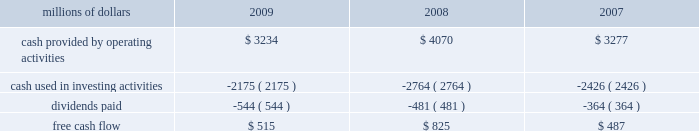2022 asset utilization 2013 in response to economic conditions and lower revenue in 2009 , we implemented productivity initiatives to improve efficiency and reduce costs , in addition to adjusting our resources to reflect lower demand .
Although varying throughout the year , our resource reductions included removing from service approximately 26% ( 26 % ) of our road locomotives and 18% ( 18 % ) of our freight car inventory by year end .
We also reduced shift levels at most rail facilities and closed or significantly reduced operations in 30 of our 114 principal rail yards .
These demand-driven resource adjustments and our productivity initiatives combined to reduce our workforce by 10% ( 10 % ) .
2022 fuel prices 2013 as the economy worsened during the third and fourth quarters of 2008 , fuel prices dropped dramatically , reaching $ 33.87 per barrel in december 2008 , a near five-year low .
Throughout 2009 , crude oil prices generally increased , ending the year around $ 80 per barrel .
Overall , our average fuel price decreased by 44% ( 44 % ) in 2009 , reducing operating expenses by $ 1.3 billion compared to 2008 .
We also reduced our consumption rate by 4% ( 4 % ) during the year , saving approximately 40 million gallons of fuel .
The use of newer , more fuel efficient locomotives ; increased use of distributed locomotive power ; fuel conservation programs ; and improved network operations and asset utilization all contributed to this improvement .
2022 free cash flow 2013 cash generated by operating activities totaled $ 3.2 billion , yielding free cash flow of $ 515 million in 2009 .
Free cash flow is defined as cash provided by operating activities , less cash used in investing activities and dividends paid .
Free cash flow is not considered a financial measure under accounting principles generally accepted in the united states ( gaap ) by sec regulation g and item 10 of sec regulation s-k .
We believe free cash flow is important in evaluating our financial performance and measures our ability to generate cash without additional external financings .
Free cash flow should be considered in addition to , rather than as a substitute for , cash provided by operating activities .
The table reconciles cash provided by operating activities ( gaap measure ) to free cash flow ( non-gaap measure ) : millions of dollars 2009 2008 2007 .
2010 outlook 2022 safety 2013 operating a safe railroad benefits our employees , our customers , our shareholders , and the public .
We will continue using a multi-faceted approach to safety , utilizing technology , risk assessment , quality control , and training , and by engaging our employees .
We will continue implementing total safety culture ( tsc ) throughout our operations .
Tsc is designed to establish , maintain , reinforce , and promote safe practices among co-workers .
This process allows us to identify and implement best practices for employee and operational safety .
Reducing grade-crossing incidents is a critical aspect of our safety programs , and we will continue our efforts to maintain , upgrade , and close crossings ; install video cameras on locomotives ; and educate the public about crossing safety through our own programs , various industry programs , and other activities .
2022 transportation plan 2013 to build upon our success in recent years , we will continue evaluating traffic flows and network logistic patterns , which can be quite dynamic from year-to-year , to identify additional opportunities to simplify operations , remove network variability and improve network efficiency and asset utilization .
We plan to adjust manpower and our locomotive and rail car fleets to .
What percent of free cash flow was distributed to shareholders in 2009? 
Computations: (544 / 515)
Answer: 1.05631. 